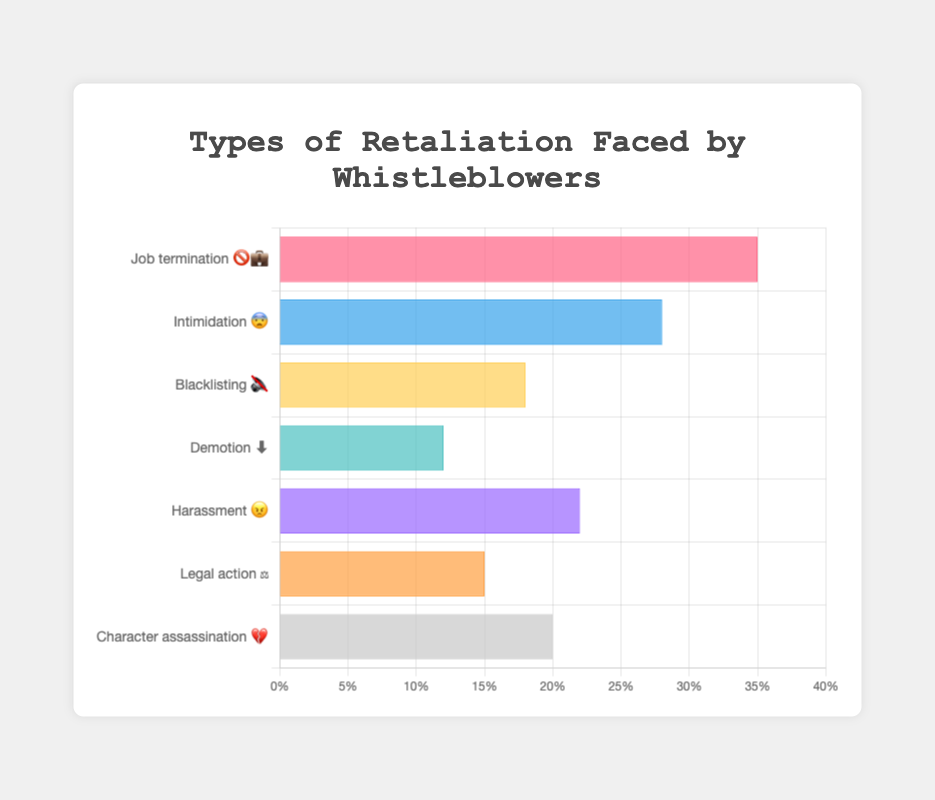What's the title of the chart? The title is displayed at the top of the chart, it helps the reader understand the main subject of the chart. The title is "Types of Retaliation Faced by Whistleblowers."
Answer: Types of Retaliation Faced by Whistleblowers What kind of retaliation has the highest percentage? The bar with the highest length represents the highest percentage. "Job termination 🚫💼" has the highest bar value of 35%.
Answer: Job termination Which type of retaliation is represented with the emoji 😠? Each type of retaliation is labeled with corresponding text and an emoji. "Harassment 😠" is represented with the emoji 😠.
Answer: Harassment What are the total percentages when you add up "Intimidation 😨" and "Character assassination 💔"? We find the percentages of both categories and add them. "Intimidation 😨" is 28% and "Character assassination 💔" is 20%. 28% + 20% = 48%.
Answer: 48% Which retaliation method is represented with both 🚫 and 💼 emojis? Each category's label includes emojis. The category with 🚫 and 💼 emojis is "Job termination 🚫💼".
Answer: Job termination Between "Blacklisting 🔇" and "Demotion ⬇️", which has a higher percentage and by how much? Compare the percentages of each. "Blacklisting 🔇" has 18% and "Demotion ⬇️" has 12%. The difference is 18% - 12% = 6%.
Answer: Blacklisting by 6% What is the combined percentage of "Legal action ⚖️" and "Demotion ⬇️"? Add the percentages of both. "Legal action ⚖️" is 15% and "Demotion ⬇️" is 12%. 15% + 12% = 27%.
Answer: 27% What is the difference in percentage between the highest and the lowest type of retaliation? Find the highest and lowest values. "Job termination 🚫💼" is highest at 35% and "Demotion ⬇️" is lowest at 12%. The difference is 35% - 12% = 23%.
Answer: 23% What type of retaliation has a percentage between "Harassment 😠" and "Legal action ⚖️"? Compare the percentages. "Harassment 😠" is 22%, and "Legal action ⚖️" is 15%. The percentage between them is 20%, which corresponds to "Character assassination 💔".
Answer: Character assassination 